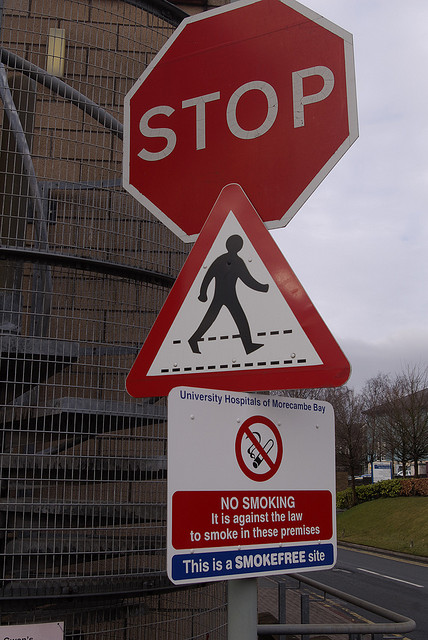<image>What is in the reflection of the stop sign? I don't know what is in the reflection of the stop sign. It seems there is nothing or could be people, sign, sun, or stop. Who is the man pictured on the sign? I don't know who the man pictured on the sign is. However, it could be a pedestrian or a walker. What is in the reflection of the stop sign? I don't know what is in the reflection of the stop sign. It is hard to determine without an image. Who is the man pictured on the sign? I don't know who the man pictured on the sign is. It can be seen as a pedestrian, walker, character, or stickman. 